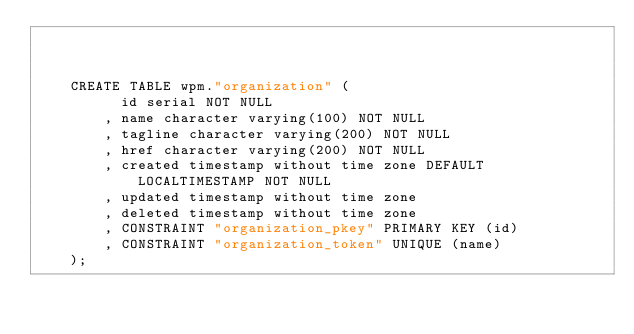<code> <loc_0><loc_0><loc_500><loc_500><_SQL_>
	

	CREATE TABLE wpm."organization" (
		  id serial NOT NULL
		, name character varying(100) NOT NULL
		, tagline character varying(200) NOT NULL
		, href character varying(200) NOT NULL
		, created timestamp without time zone DEFAULT LOCALTIMESTAMP NOT NULL
		, updated timestamp without time zone
		, deleted timestamp without time zone
	  	, CONSTRAINT "organization_pkey" PRIMARY KEY (id)
	  	, CONSTRAINT "organization_token" UNIQUE (name)
	);</code> 